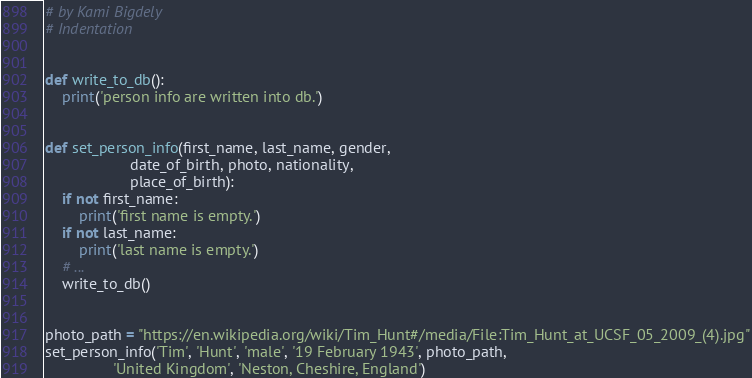Convert code to text. <code><loc_0><loc_0><loc_500><loc_500><_Python_># by Kami Bigdely
# Indentation


def write_to_db():
    print('person info are written into db.')


def set_person_info(first_name, last_name, gender,
                    date_of_birth, photo, nationality,
                    place_of_birth):
    if not first_name:
        print('first name is empty.')
    if not last_name:
        print('last name is empty.')
    # ...
    write_to_db()


photo_path = "https://en.wikipedia.org/wiki/Tim_Hunt#/media/File:Tim_Hunt_at_UCSF_05_2009_(4).jpg"
set_person_info('Tim', 'Hunt', 'male', '19 February 1943', photo_path,
                'United Kingdom', 'Neston, Cheshire, England')
</code> 